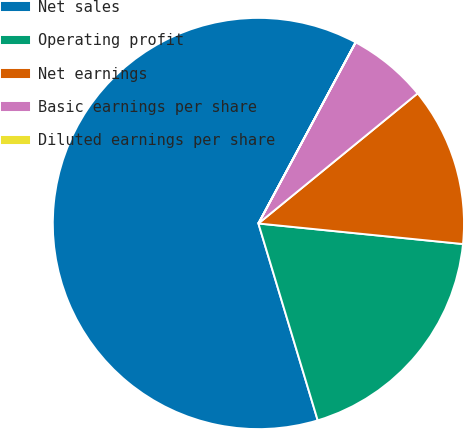Convert chart. <chart><loc_0><loc_0><loc_500><loc_500><pie_chart><fcel>Net sales<fcel>Operating profit<fcel>Net earnings<fcel>Basic earnings per share<fcel>Diluted earnings per share<nl><fcel>62.49%<fcel>18.75%<fcel>12.5%<fcel>6.25%<fcel>0.01%<nl></chart> 